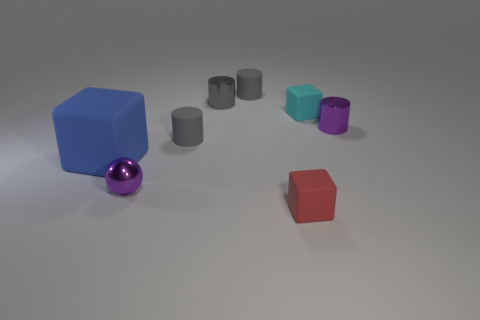Subtract all cyan rubber cubes. How many cubes are left? 2 Subtract all balls. How many objects are left? 7 Add 1 cyan objects. How many objects exist? 9 Subtract all purple cylinders. How many cylinders are left? 3 Subtract 1 cyan blocks. How many objects are left? 7 Subtract 1 balls. How many balls are left? 0 Subtract all green cylinders. Subtract all yellow blocks. How many cylinders are left? 4 Subtract all cyan balls. How many purple cylinders are left? 1 Subtract all big rubber cubes. Subtract all big blue cubes. How many objects are left? 6 Add 3 cyan rubber objects. How many cyan rubber objects are left? 4 